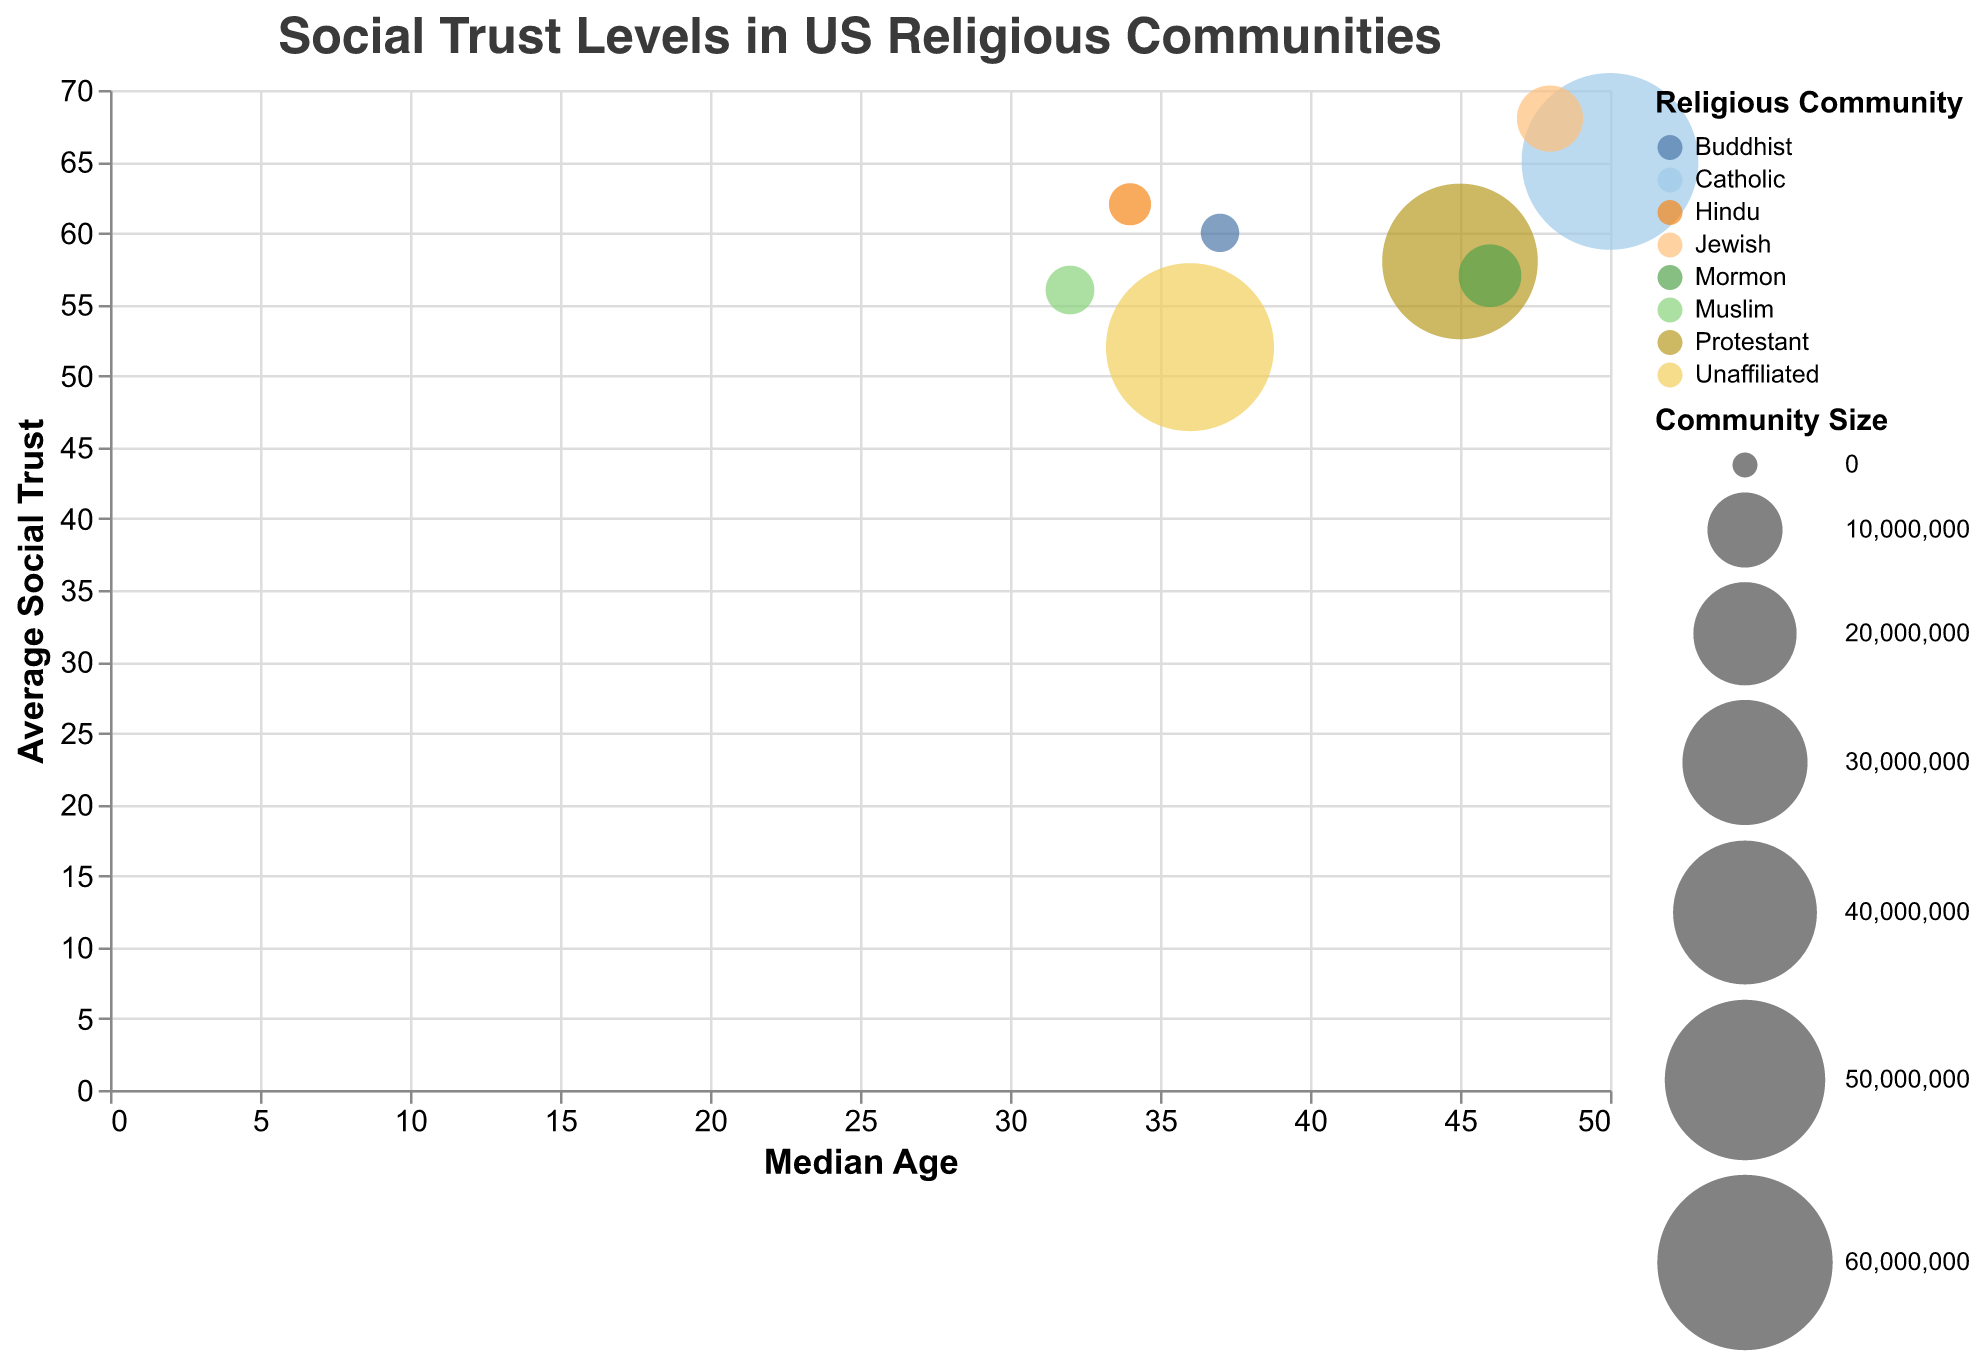How many religious communities are displayed in the figure? The title of the chart indicates that it's about religious communities, and the legend shows the colors representing different communities. We can count the number of unique colors/labels in the legend to get the number of religious communities.
Answer: 8 Which religious community has the highest average social trust? Look at the y-axis titled "Average Social Trust" and identify the bubble whose center is positioned the highest along this axis. Refer to the tooltip to confirm the religious community.
Answer: Jewish What is the relationship between average social trust and median age for the Protestant community? Locate the bubble representing the Protestant community using the legend. Observe its position on both the x-axis (median age) and y-axis (average social trust).
Answer: 58 trust, 45 age Which religious community has the smallest community size, and what is its average social trust? Identify the smallest bubble by size according to the legend for "Community Size," and then check the tooltip for the average social trust associated with this bubble.
Answer: Buddhist, 60 Compare the median age of the Catholic and Hindu communities. Which one has a higher median age and by how much? Identify the bubbles for Catholic and Hindu communities on the x-axis. The Catholic bubble is further to the right. The tooltip indicates the ages.
Answer: Catholic (50) is higher than Hindu (34) by 16 Is there any religious community with both a median age below 40 and an average social trust below 60? Look along the x-axis for bubbles positioned below the 40 mark and y-axis below the 60 mark. Verify with the tooltip data.
Answer: Yes, Unaffiliated (36, 52) and Muslim (32, 56) Calculate the average community size for the Jewish and Mormon communities. Look at the sizes of bubbles labeled Jewish and Mormon, then use the tooltip to get their community sizes: 7,500,000 (Jewish) and 6,600,000 (Mormon). Calculate the average: (7,500,000 + 6,600,000) / 2.
Answer: 7,050,000 Which religious community with a median age above 40 has the lowest average social trust? Focus on bubbles to the right of the 40 mark on the x-axis. Among those, find the bubble positioned lowest along the y-axis. Confirm using the tooltip.
Answer: Mormon (57) Do larger communities tend to have higher average social trust? Observe the sizes and positions of the bubbles along the y-axis to discern any pattern, but it's evident that the larger bubbles (farther right) do not consistently align with higher positions (average social trust).
Answer: Not necessarily Among the religious communities with a median age of less than 40, which one has the highest average social trust? Identify bubbles to the left of 40 on the x-axis. Among these, the highest on the y-axis reveals the community. Confirm with the tooltip.
Answer: Hindu 